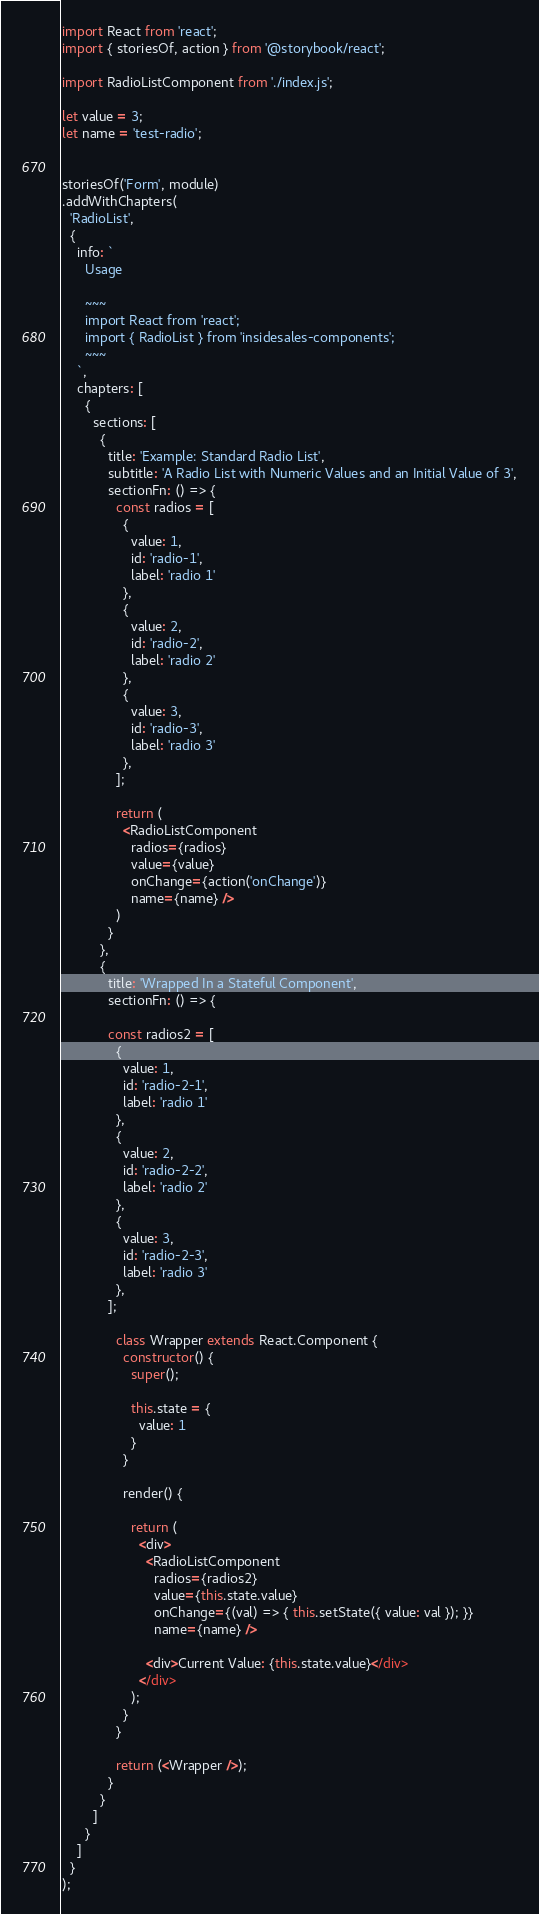<code> <loc_0><loc_0><loc_500><loc_500><_JavaScript_>import React from 'react';
import { storiesOf, action } from '@storybook/react';

import RadioListComponent from './index.js';

let value = 3;
let name = 'test-radio';


storiesOf('Form', module)
.addWithChapters(
  'RadioList',
  {
    info: `
      Usage

      ~~~
      import React from 'react';
      import { RadioList } from 'insidesales-components';
      ~~~
    `,
    chapters: [
      {
        sections: [
          {
            title: 'Example: Standard Radio List',
            subtitle: 'A Radio List with Numeric Values and an Initial Value of 3',
            sectionFn: () => {
              const radios = [
                {
                  value: 1,
                  id: 'radio-1',
                  label: 'radio 1'
                },
                {
                  value: 2,
                  id: 'radio-2',
                  label: 'radio 2'
                },
                {
                  value: 3,
                  id: 'radio-3',
                  label: 'radio 3'
                },
              ];
              
              return (
                <RadioListComponent
                  radios={radios}
                  value={value}
                  onChange={action('onChange')}
                  name={name} />
              )
            }
          },
          {
            title: 'Wrapped In a Stateful Component',
            sectionFn: () => {

            const radios2 = [
              {
                value: 1,
                id: 'radio-2-1',
                label: 'radio 1'
              },
              {
                value: 2,
                id: 'radio-2-2',
                label: 'radio 2'
              },
              {
                value: 3,
                id: 'radio-2-3',
                label: 'radio 3'
              },
            ];

              class Wrapper extends React.Component {
                constructor() {
                  super();

                  this.state = {
                    value: 1
                  }
                }

                render() {

                  return (
                    <div>
                      <RadioListComponent
                        radios={radios2}
                        value={this.state.value}
                        onChange={(val) => { this.setState({ value: val }); }}
                        name={name} />

                      <div>Current Value: {this.state.value}</div>
                    </div>
                  );
                }
              }

              return (<Wrapper />);
            }
          }
        ]
      }
    ]
  }
);</code> 